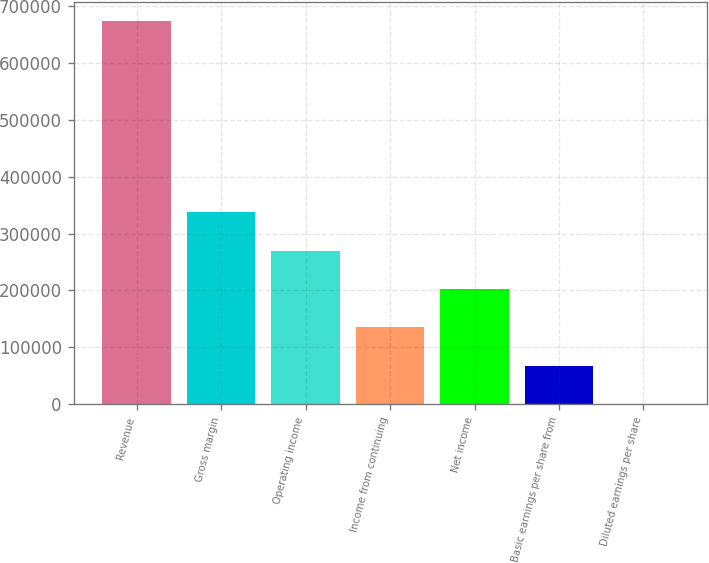Convert chart. <chart><loc_0><loc_0><loc_500><loc_500><bar_chart><fcel>Revenue<fcel>Gross margin<fcel>Operating income<fcel>Income from continuing<fcel>Net income<fcel>Basic earnings per share from<fcel>Diluted earnings per share<nl><fcel>674063<fcel>337032<fcel>269625<fcel>134813<fcel>202219<fcel>67406.6<fcel>0.28<nl></chart> 